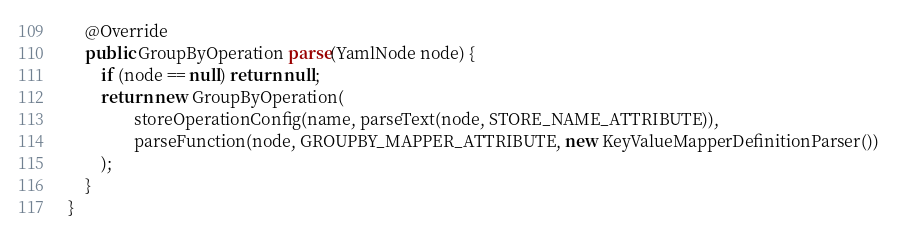<code> <loc_0><loc_0><loc_500><loc_500><_Java_>
    @Override
    public GroupByOperation parse(YamlNode node) {
        if (node == null) return null;
        return new GroupByOperation(
                storeOperationConfig(name, parseText(node, STORE_NAME_ATTRIBUTE)),
                parseFunction(node, GROUPBY_MAPPER_ATTRIBUTE, new KeyValueMapperDefinitionParser())
        );
    }
}
</code> 